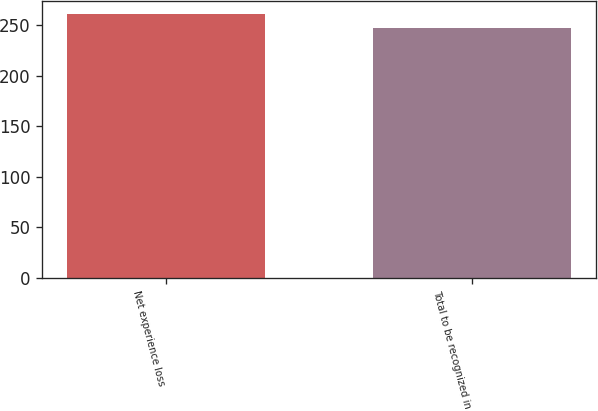Convert chart to OTSL. <chart><loc_0><loc_0><loc_500><loc_500><bar_chart><fcel>Net experience loss<fcel>Total to be recognized in<nl><fcel>261<fcel>247<nl></chart> 